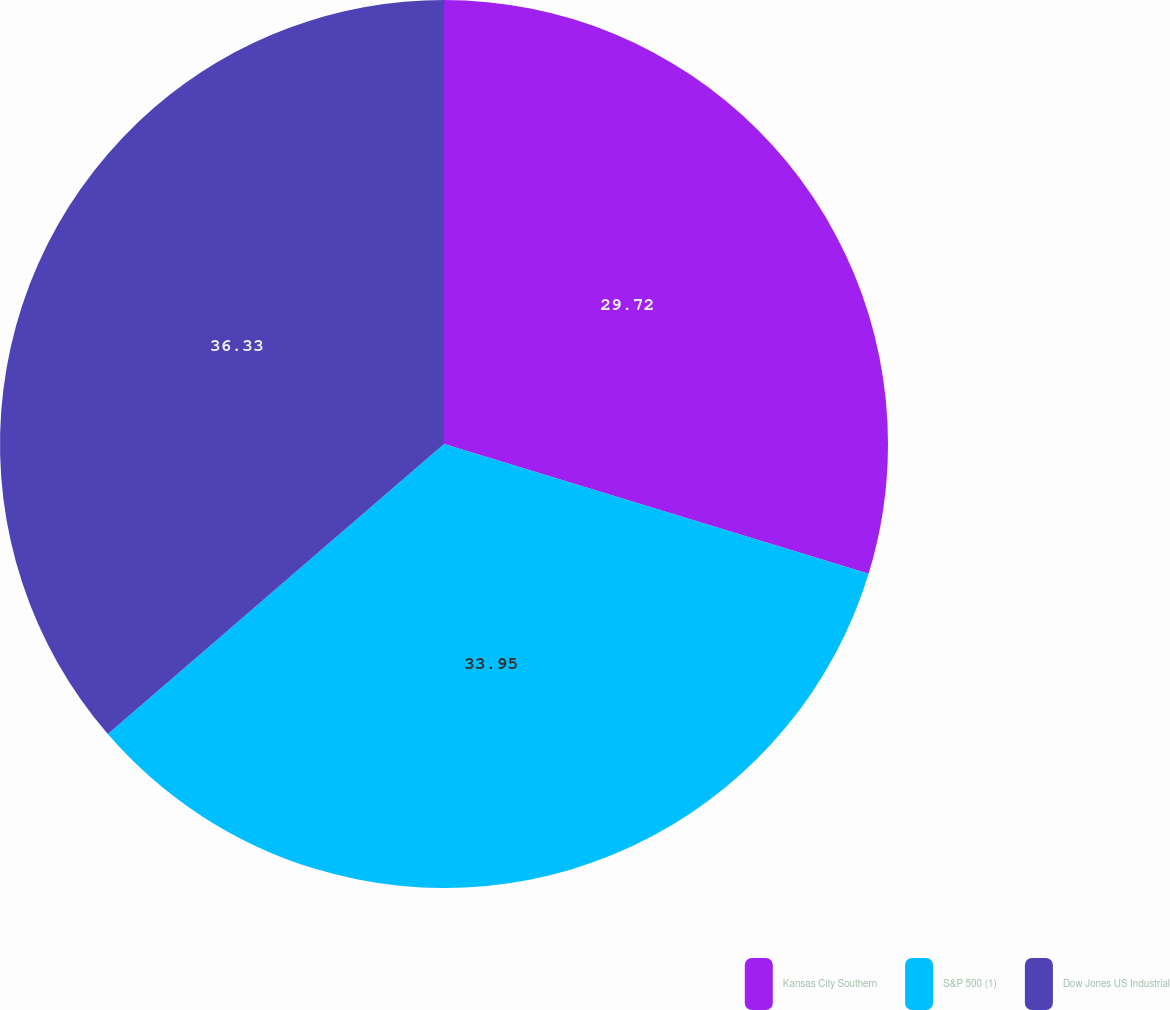Convert chart. <chart><loc_0><loc_0><loc_500><loc_500><pie_chart><fcel>Kansas City Southern<fcel>S&P 500 (1)<fcel>Dow Jones US Industrial<nl><fcel>29.72%<fcel>33.95%<fcel>36.33%<nl></chart> 